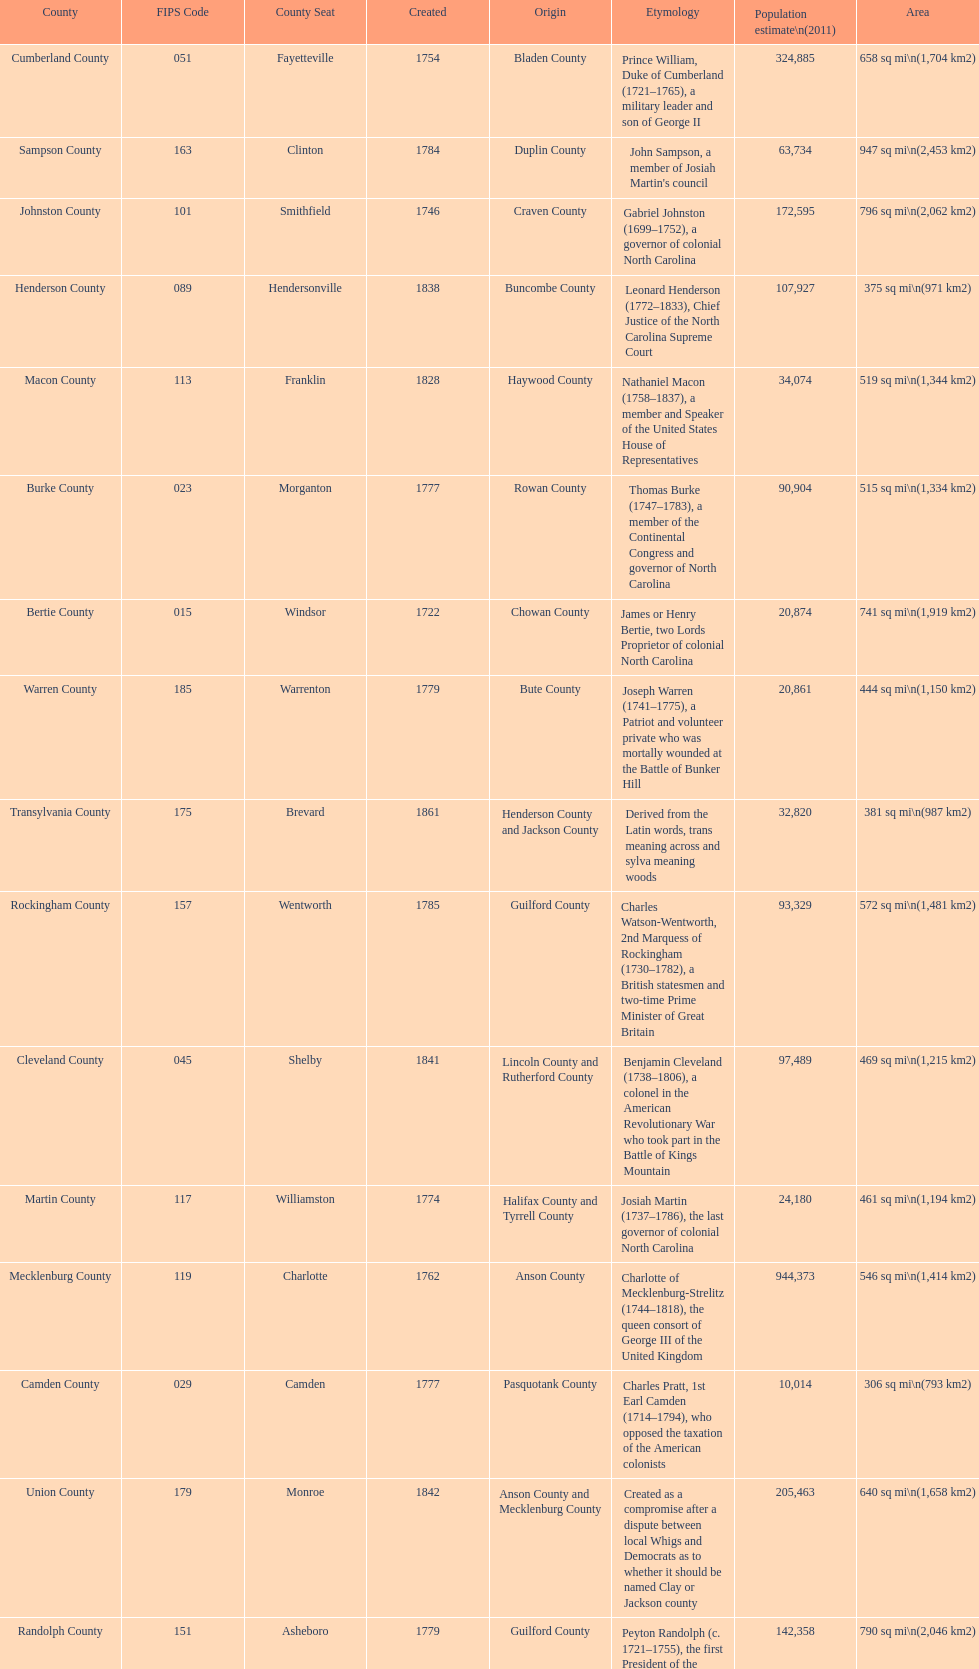What number of counties are named for us presidents? 3. 